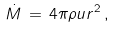<formula> <loc_0><loc_0><loc_500><loc_500>\dot { M } \, = \, 4 \pi \rho u r ^ { 2 } \, ,</formula> 